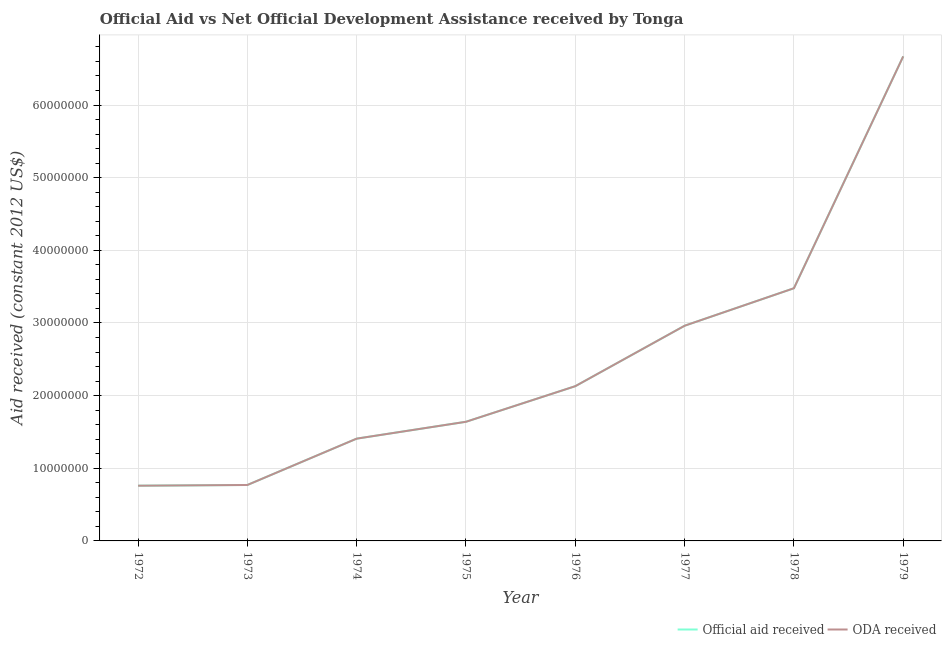How many different coloured lines are there?
Ensure brevity in your answer.  2. Does the line corresponding to official aid received intersect with the line corresponding to oda received?
Ensure brevity in your answer.  Yes. What is the official aid received in 1974?
Your answer should be compact. 1.41e+07. Across all years, what is the maximum official aid received?
Ensure brevity in your answer.  6.67e+07. Across all years, what is the minimum official aid received?
Offer a terse response. 7.60e+06. In which year was the official aid received maximum?
Offer a very short reply. 1979. What is the total official aid received in the graph?
Provide a succinct answer. 1.98e+08. What is the difference between the official aid received in 1974 and that in 1975?
Provide a succinct answer. -2.32e+06. What is the difference between the oda received in 1973 and the official aid received in 1978?
Provide a short and direct response. -2.71e+07. What is the average oda received per year?
Make the answer very short. 2.48e+07. In the year 1978, what is the difference between the oda received and official aid received?
Your answer should be very brief. 0. What is the ratio of the official aid received in 1972 to that in 1978?
Your answer should be compact. 0.22. Is the oda received in 1976 less than that in 1977?
Your response must be concise. Yes. Is the difference between the official aid received in 1974 and 1978 greater than the difference between the oda received in 1974 and 1978?
Your answer should be compact. No. What is the difference between the highest and the second highest oda received?
Keep it short and to the point. 3.19e+07. What is the difference between the highest and the lowest official aid received?
Offer a very short reply. 5.91e+07. Does the oda received monotonically increase over the years?
Offer a very short reply. Yes. Is the oda received strictly greater than the official aid received over the years?
Keep it short and to the point. No. Is the official aid received strictly less than the oda received over the years?
Your answer should be very brief. No. What is the difference between two consecutive major ticks on the Y-axis?
Your answer should be very brief. 1.00e+07. Does the graph contain grids?
Offer a very short reply. Yes. Where does the legend appear in the graph?
Your answer should be compact. Bottom right. What is the title of the graph?
Offer a terse response. Official Aid vs Net Official Development Assistance received by Tonga . What is the label or title of the Y-axis?
Provide a succinct answer. Aid received (constant 2012 US$). What is the Aid received (constant 2012 US$) in Official aid received in 1972?
Offer a terse response. 7.60e+06. What is the Aid received (constant 2012 US$) in ODA received in 1972?
Make the answer very short. 7.60e+06. What is the Aid received (constant 2012 US$) of Official aid received in 1973?
Offer a terse response. 7.70e+06. What is the Aid received (constant 2012 US$) in ODA received in 1973?
Your answer should be very brief. 7.70e+06. What is the Aid received (constant 2012 US$) of Official aid received in 1974?
Give a very brief answer. 1.41e+07. What is the Aid received (constant 2012 US$) of ODA received in 1974?
Offer a very short reply. 1.41e+07. What is the Aid received (constant 2012 US$) in Official aid received in 1975?
Provide a succinct answer. 1.64e+07. What is the Aid received (constant 2012 US$) of ODA received in 1975?
Ensure brevity in your answer.  1.64e+07. What is the Aid received (constant 2012 US$) in Official aid received in 1976?
Provide a succinct answer. 2.13e+07. What is the Aid received (constant 2012 US$) in ODA received in 1976?
Offer a very short reply. 2.13e+07. What is the Aid received (constant 2012 US$) of Official aid received in 1977?
Your answer should be very brief. 2.96e+07. What is the Aid received (constant 2012 US$) in ODA received in 1977?
Your answer should be very brief. 2.96e+07. What is the Aid received (constant 2012 US$) of Official aid received in 1978?
Offer a terse response. 3.48e+07. What is the Aid received (constant 2012 US$) in ODA received in 1978?
Your answer should be very brief. 3.48e+07. What is the Aid received (constant 2012 US$) of Official aid received in 1979?
Your answer should be very brief. 6.67e+07. What is the Aid received (constant 2012 US$) of ODA received in 1979?
Keep it short and to the point. 6.67e+07. Across all years, what is the maximum Aid received (constant 2012 US$) of Official aid received?
Your answer should be very brief. 6.67e+07. Across all years, what is the maximum Aid received (constant 2012 US$) in ODA received?
Your answer should be compact. 6.67e+07. Across all years, what is the minimum Aid received (constant 2012 US$) of Official aid received?
Offer a very short reply. 7.60e+06. Across all years, what is the minimum Aid received (constant 2012 US$) in ODA received?
Your answer should be very brief. 7.60e+06. What is the total Aid received (constant 2012 US$) in Official aid received in the graph?
Provide a short and direct response. 1.98e+08. What is the total Aid received (constant 2012 US$) in ODA received in the graph?
Ensure brevity in your answer.  1.98e+08. What is the difference between the Aid received (constant 2012 US$) in Official aid received in 1972 and that in 1974?
Offer a very short reply. -6.48e+06. What is the difference between the Aid received (constant 2012 US$) in ODA received in 1972 and that in 1974?
Ensure brevity in your answer.  -6.48e+06. What is the difference between the Aid received (constant 2012 US$) in Official aid received in 1972 and that in 1975?
Your response must be concise. -8.80e+06. What is the difference between the Aid received (constant 2012 US$) of ODA received in 1972 and that in 1975?
Your answer should be compact. -8.80e+06. What is the difference between the Aid received (constant 2012 US$) of Official aid received in 1972 and that in 1976?
Provide a short and direct response. -1.37e+07. What is the difference between the Aid received (constant 2012 US$) in ODA received in 1972 and that in 1976?
Offer a very short reply. -1.37e+07. What is the difference between the Aid received (constant 2012 US$) of Official aid received in 1972 and that in 1977?
Your answer should be very brief. -2.20e+07. What is the difference between the Aid received (constant 2012 US$) of ODA received in 1972 and that in 1977?
Your answer should be compact. -2.20e+07. What is the difference between the Aid received (constant 2012 US$) in Official aid received in 1972 and that in 1978?
Make the answer very short. -2.72e+07. What is the difference between the Aid received (constant 2012 US$) of ODA received in 1972 and that in 1978?
Make the answer very short. -2.72e+07. What is the difference between the Aid received (constant 2012 US$) in Official aid received in 1972 and that in 1979?
Keep it short and to the point. -5.91e+07. What is the difference between the Aid received (constant 2012 US$) in ODA received in 1972 and that in 1979?
Offer a terse response. -5.91e+07. What is the difference between the Aid received (constant 2012 US$) in Official aid received in 1973 and that in 1974?
Your response must be concise. -6.38e+06. What is the difference between the Aid received (constant 2012 US$) in ODA received in 1973 and that in 1974?
Your response must be concise. -6.38e+06. What is the difference between the Aid received (constant 2012 US$) of Official aid received in 1973 and that in 1975?
Ensure brevity in your answer.  -8.70e+06. What is the difference between the Aid received (constant 2012 US$) in ODA received in 1973 and that in 1975?
Provide a succinct answer. -8.70e+06. What is the difference between the Aid received (constant 2012 US$) in Official aid received in 1973 and that in 1976?
Provide a succinct answer. -1.36e+07. What is the difference between the Aid received (constant 2012 US$) in ODA received in 1973 and that in 1976?
Your answer should be compact. -1.36e+07. What is the difference between the Aid received (constant 2012 US$) of Official aid received in 1973 and that in 1977?
Provide a succinct answer. -2.19e+07. What is the difference between the Aid received (constant 2012 US$) of ODA received in 1973 and that in 1977?
Your answer should be very brief. -2.19e+07. What is the difference between the Aid received (constant 2012 US$) of Official aid received in 1973 and that in 1978?
Keep it short and to the point. -2.71e+07. What is the difference between the Aid received (constant 2012 US$) in ODA received in 1973 and that in 1978?
Offer a terse response. -2.71e+07. What is the difference between the Aid received (constant 2012 US$) of Official aid received in 1973 and that in 1979?
Provide a short and direct response. -5.90e+07. What is the difference between the Aid received (constant 2012 US$) in ODA received in 1973 and that in 1979?
Offer a very short reply. -5.90e+07. What is the difference between the Aid received (constant 2012 US$) in Official aid received in 1974 and that in 1975?
Ensure brevity in your answer.  -2.32e+06. What is the difference between the Aid received (constant 2012 US$) of ODA received in 1974 and that in 1975?
Give a very brief answer. -2.32e+06. What is the difference between the Aid received (constant 2012 US$) in Official aid received in 1974 and that in 1976?
Ensure brevity in your answer.  -7.22e+06. What is the difference between the Aid received (constant 2012 US$) of ODA received in 1974 and that in 1976?
Keep it short and to the point. -7.22e+06. What is the difference between the Aid received (constant 2012 US$) in Official aid received in 1974 and that in 1977?
Ensure brevity in your answer.  -1.55e+07. What is the difference between the Aid received (constant 2012 US$) of ODA received in 1974 and that in 1977?
Give a very brief answer. -1.55e+07. What is the difference between the Aid received (constant 2012 US$) of Official aid received in 1974 and that in 1978?
Keep it short and to the point. -2.07e+07. What is the difference between the Aid received (constant 2012 US$) of ODA received in 1974 and that in 1978?
Ensure brevity in your answer.  -2.07e+07. What is the difference between the Aid received (constant 2012 US$) in Official aid received in 1974 and that in 1979?
Give a very brief answer. -5.26e+07. What is the difference between the Aid received (constant 2012 US$) in ODA received in 1974 and that in 1979?
Offer a terse response. -5.26e+07. What is the difference between the Aid received (constant 2012 US$) of Official aid received in 1975 and that in 1976?
Offer a very short reply. -4.90e+06. What is the difference between the Aid received (constant 2012 US$) of ODA received in 1975 and that in 1976?
Your answer should be very brief. -4.90e+06. What is the difference between the Aid received (constant 2012 US$) of Official aid received in 1975 and that in 1977?
Offer a terse response. -1.32e+07. What is the difference between the Aid received (constant 2012 US$) of ODA received in 1975 and that in 1977?
Offer a very short reply. -1.32e+07. What is the difference between the Aid received (constant 2012 US$) of Official aid received in 1975 and that in 1978?
Provide a succinct answer. -1.84e+07. What is the difference between the Aid received (constant 2012 US$) in ODA received in 1975 and that in 1978?
Your answer should be compact. -1.84e+07. What is the difference between the Aid received (constant 2012 US$) of Official aid received in 1975 and that in 1979?
Offer a terse response. -5.03e+07. What is the difference between the Aid received (constant 2012 US$) of ODA received in 1975 and that in 1979?
Offer a terse response. -5.03e+07. What is the difference between the Aid received (constant 2012 US$) of Official aid received in 1976 and that in 1977?
Ensure brevity in your answer.  -8.32e+06. What is the difference between the Aid received (constant 2012 US$) of ODA received in 1976 and that in 1977?
Provide a short and direct response. -8.32e+06. What is the difference between the Aid received (constant 2012 US$) of Official aid received in 1976 and that in 1978?
Give a very brief answer. -1.35e+07. What is the difference between the Aid received (constant 2012 US$) of ODA received in 1976 and that in 1978?
Ensure brevity in your answer.  -1.35e+07. What is the difference between the Aid received (constant 2012 US$) in Official aid received in 1976 and that in 1979?
Offer a terse response. -4.54e+07. What is the difference between the Aid received (constant 2012 US$) in ODA received in 1976 and that in 1979?
Your response must be concise. -4.54e+07. What is the difference between the Aid received (constant 2012 US$) of Official aid received in 1977 and that in 1978?
Offer a very short reply. -5.16e+06. What is the difference between the Aid received (constant 2012 US$) of ODA received in 1977 and that in 1978?
Provide a short and direct response. -5.16e+06. What is the difference between the Aid received (constant 2012 US$) of Official aid received in 1977 and that in 1979?
Your response must be concise. -3.71e+07. What is the difference between the Aid received (constant 2012 US$) in ODA received in 1977 and that in 1979?
Offer a very short reply. -3.71e+07. What is the difference between the Aid received (constant 2012 US$) of Official aid received in 1978 and that in 1979?
Make the answer very short. -3.19e+07. What is the difference between the Aid received (constant 2012 US$) of ODA received in 1978 and that in 1979?
Make the answer very short. -3.19e+07. What is the difference between the Aid received (constant 2012 US$) in Official aid received in 1972 and the Aid received (constant 2012 US$) in ODA received in 1973?
Give a very brief answer. -1.00e+05. What is the difference between the Aid received (constant 2012 US$) of Official aid received in 1972 and the Aid received (constant 2012 US$) of ODA received in 1974?
Provide a succinct answer. -6.48e+06. What is the difference between the Aid received (constant 2012 US$) of Official aid received in 1972 and the Aid received (constant 2012 US$) of ODA received in 1975?
Ensure brevity in your answer.  -8.80e+06. What is the difference between the Aid received (constant 2012 US$) in Official aid received in 1972 and the Aid received (constant 2012 US$) in ODA received in 1976?
Ensure brevity in your answer.  -1.37e+07. What is the difference between the Aid received (constant 2012 US$) in Official aid received in 1972 and the Aid received (constant 2012 US$) in ODA received in 1977?
Give a very brief answer. -2.20e+07. What is the difference between the Aid received (constant 2012 US$) of Official aid received in 1972 and the Aid received (constant 2012 US$) of ODA received in 1978?
Make the answer very short. -2.72e+07. What is the difference between the Aid received (constant 2012 US$) in Official aid received in 1972 and the Aid received (constant 2012 US$) in ODA received in 1979?
Give a very brief answer. -5.91e+07. What is the difference between the Aid received (constant 2012 US$) of Official aid received in 1973 and the Aid received (constant 2012 US$) of ODA received in 1974?
Your response must be concise. -6.38e+06. What is the difference between the Aid received (constant 2012 US$) of Official aid received in 1973 and the Aid received (constant 2012 US$) of ODA received in 1975?
Your response must be concise. -8.70e+06. What is the difference between the Aid received (constant 2012 US$) of Official aid received in 1973 and the Aid received (constant 2012 US$) of ODA received in 1976?
Offer a terse response. -1.36e+07. What is the difference between the Aid received (constant 2012 US$) of Official aid received in 1973 and the Aid received (constant 2012 US$) of ODA received in 1977?
Your response must be concise. -2.19e+07. What is the difference between the Aid received (constant 2012 US$) in Official aid received in 1973 and the Aid received (constant 2012 US$) in ODA received in 1978?
Your answer should be compact. -2.71e+07. What is the difference between the Aid received (constant 2012 US$) in Official aid received in 1973 and the Aid received (constant 2012 US$) in ODA received in 1979?
Your answer should be very brief. -5.90e+07. What is the difference between the Aid received (constant 2012 US$) in Official aid received in 1974 and the Aid received (constant 2012 US$) in ODA received in 1975?
Your answer should be compact. -2.32e+06. What is the difference between the Aid received (constant 2012 US$) of Official aid received in 1974 and the Aid received (constant 2012 US$) of ODA received in 1976?
Your response must be concise. -7.22e+06. What is the difference between the Aid received (constant 2012 US$) of Official aid received in 1974 and the Aid received (constant 2012 US$) of ODA received in 1977?
Make the answer very short. -1.55e+07. What is the difference between the Aid received (constant 2012 US$) of Official aid received in 1974 and the Aid received (constant 2012 US$) of ODA received in 1978?
Your answer should be very brief. -2.07e+07. What is the difference between the Aid received (constant 2012 US$) in Official aid received in 1974 and the Aid received (constant 2012 US$) in ODA received in 1979?
Your response must be concise. -5.26e+07. What is the difference between the Aid received (constant 2012 US$) of Official aid received in 1975 and the Aid received (constant 2012 US$) of ODA received in 1976?
Provide a succinct answer. -4.90e+06. What is the difference between the Aid received (constant 2012 US$) of Official aid received in 1975 and the Aid received (constant 2012 US$) of ODA received in 1977?
Make the answer very short. -1.32e+07. What is the difference between the Aid received (constant 2012 US$) in Official aid received in 1975 and the Aid received (constant 2012 US$) in ODA received in 1978?
Give a very brief answer. -1.84e+07. What is the difference between the Aid received (constant 2012 US$) in Official aid received in 1975 and the Aid received (constant 2012 US$) in ODA received in 1979?
Your answer should be compact. -5.03e+07. What is the difference between the Aid received (constant 2012 US$) of Official aid received in 1976 and the Aid received (constant 2012 US$) of ODA received in 1977?
Keep it short and to the point. -8.32e+06. What is the difference between the Aid received (constant 2012 US$) of Official aid received in 1976 and the Aid received (constant 2012 US$) of ODA received in 1978?
Provide a succinct answer. -1.35e+07. What is the difference between the Aid received (constant 2012 US$) in Official aid received in 1976 and the Aid received (constant 2012 US$) in ODA received in 1979?
Offer a terse response. -4.54e+07. What is the difference between the Aid received (constant 2012 US$) of Official aid received in 1977 and the Aid received (constant 2012 US$) of ODA received in 1978?
Make the answer very short. -5.16e+06. What is the difference between the Aid received (constant 2012 US$) in Official aid received in 1977 and the Aid received (constant 2012 US$) in ODA received in 1979?
Provide a succinct answer. -3.71e+07. What is the difference between the Aid received (constant 2012 US$) of Official aid received in 1978 and the Aid received (constant 2012 US$) of ODA received in 1979?
Give a very brief answer. -3.19e+07. What is the average Aid received (constant 2012 US$) in Official aid received per year?
Keep it short and to the point. 2.48e+07. What is the average Aid received (constant 2012 US$) in ODA received per year?
Your answer should be very brief. 2.48e+07. In the year 1977, what is the difference between the Aid received (constant 2012 US$) in Official aid received and Aid received (constant 2012 US$) in ODA received?
Offer a very short reply. 0. In the year 1979, what is the difference between the Aid received (constant 2012 US$) in Official aid received and Aid received (constant 2012 US$) in ODA received?
Ensure brevity in your answer.  0. What is the ratio of the Aid received (constant 2012 US$) in Official aid received in 1972 to that in 1974?
Offer a very short reply. 0.54. What is the ratio of the Aid received (constant 2012 US$) in ODA received in 1972 to that in 1974?
Ensure brevity in your answer.  0.54. What is the ratio of the Aid received (constant 2012 US$) of Official aid received in 1972 to that in 1975?
Your response must be concise. 0.46. What is the ratio of the Aid received (constant 2012 US$) in ODA received in 1972 to that in 1975?
Give a very brief answer. 0.46. What is the ratio of the Aid received (constant 2012 US$) in Official aid received in 1972 to that in 1976?
Offer a terse response. 0.36. What is the ratio of the Aid received (constant 2012 US$) in ODA received in 1972 to that in 1976?
Keep it short and to the point. 0.36. What is the ratio of the Aid received (constant 2012 US$) of Official aid received in 1972 to that in 1977?
Give a very brief answer. 0.26. What is the ratio of the Aid received (constant 2012 US$) in ODA received in 1972 to that in 1977?
Offer a very short reply. 0.26. What is the ratio of the Aid received (constant 2012 US$) in Official aid received in 1972 to that in 1978?
Offer a very short reply. 0.22. What is the ratio of the Aid received (constant 2012 US$) of ODA received in 1972 to that in 1978?
Offer a very short reply. 0.22. What is the ratio of the Aid received (constant 2012 US$) of Official aid received in 1972 to that in 1979?
Offer a terse response. 0.11. What is the ratio of the Aid received (constant 2012 US$) in ODA received in 1972 to that in 1979?
Provide a succinct answer. 0.11. What is the ratio of the Aid received (constant 2012 US$) of Official aid received in 1973 to that in 1974?
Offer a very short reply. 0.55. What is the ratio of the Aid received (constant 2012 US$) in ODA received in 1973 to that in 1974?
Your response must be concise. 0.55. What is the ratio of the Aid received (constant 2012 US$) of Official aid received in 1973 to that in 1975?
Your answer should be compact. 0.47. What is the ratio of the Aid received (constant 2012 US$) in ODA received in 1973 to that in 1975?
Your answer should be very brief. 0.47. What is the ratio of the Aid received (constant 2012 US$) of Official aid received in 1973 to that in 1976?
Offer a terse response. 0.36. What is the ratio of the Aid received (constant 2012 US$) in ODA received in 1973 to that in 1976?
Give a very brief answer. 0.36. What is the ratio of the Aid received (constant 2012 US$) in Official aid received in 1973 to that in 1977?
Provide a succinct answer. 0.26. What is the ratio of the Aid received (constant 2012 US$) of ODA received in 1973 to that in 1977?
Your answer should be compact. 0.26. What is the ratio of the Aid received (constant 2012 US$) of Official aid received in 1973 to that in 1978?
Ensure brevity in your answer.  0.22. What is the ratio of the Aid received (constant 2012 US$) in ODA received in 1973 to that in 1978?
Your response must be concise. 0.22. What is the ratio of the Aid received (constant 2012 US$) of Official aid received in 1973 to that in 1979?
Your response must be concise. 0.12. What is the ratio of the Aid received (constant 2012 US$) of ODA received in 1973 to that in 1979?
Give a very brief answer. 0.12. What is the ratio of the Aid received (constant 2012 US$) in Official aid received in 1974 to that in 1975?
Your answer should be compact. 0.86. What is the ratio of the Aid received (constant 2012 US$) in ODA received in 1974 to that in 1975?
Make the answer very short. 0.86. What is the ratio of the Aid received (constant 2012 US$) in Official aid received in 1974 to that in 1976?
Keep it short and to the point. 0.66. What is the ratio of the Aid received (constant 2012 US$) of ODA received in 1974 to that in 1976?
Your answer should be compact. 0.66. What is the ratio of the Aid received (constant 2012 US$) in Official aid received in 1974 to that in 1977?
Provide a short and direct response. 0.48. What is the ratio of the Aid received (constant 2012 US$) in ODA received in 1974 to that in 1977?
Your response must be concise. 0.48. What is the ratio of the Aid received (constant 2012 US$) of Official aid received in 1974 to that in 1978?
Your answer should be compact. 0.4. What is the ratio of the Aid received (constant 2012 US$) in ODA received in 1974 to that in 1978?
Make the answer very short. 0.4. What is the ratio of the Aid received (constant 2012 US$) of Official aid received in 1974 to that in 1979?
Provide a short and direct response. 0.21. What is the ratio of the Aid received (constant 2012 US$) of ODA received in 1974 to that in 1979?
Offer a terse response. 0.21. What is the ratio of the Aid received (constant 2012 US$) in Official aid received in 1975 to that in 1976?
Your answer should be very brief. 0.77. What is the ratio of the Aid received (constant 2012 US$) of ODA received in 1975 to that in 1976?
Your answer should be very brief. 0.77. What is the ratio of the Aid received (constant 2012 US$) of Official aid received in 1975 to that in 1977?
Provide a succinct answer. 0.55. What is the ratio of the Aid received (constant 2012 US$) of ODA received in 1975 to that in 1977?
Keep it short and to the point. 0.55. What is the ratio of the Aid received (constant 2012 US$) in Official aid received in 1975 to that in 1978?
Your answer should be compact. 0.47. What is the ratio of the Aid received (constant 2012 US$) of ODA received in 1975 to that in 1978?
Keep it short and to the point. 0.47. What is the ratio of the Aid received (constant 2012 US$) in Official aid received in 1975 to that in 1979?
Provide a succinct answer. 0.25. What is the ratio of the Aid received (constant 2012 US$) in ODA received in 1975 to that in 1979?
Offer a terse response. 0.25. What is the ratio of the Aid received (constant 2012 US$) of Official aid received in 1976 to that in 1977?
Offer a very short reply. 0.72. What is the ratio of the Aid received (constant 2012 US$) in ODA received in 1976 to that in 1977?
Offer a terse response. 0.72. What is the ratio of the Aid received (constant 2012 US$) in Official aid received in 1976 to that in 1978?
Offer a very short reply. 0.61. What is the ratio of the Aid received (constant 2012 US$) of ODA received in 1976 to that in 1978?
Make the answer very short. 0.61. What is the ratio of the Aid received (constant 2012 US$) of Official aid received in 1976 to that in 1979?
Make the answer very short. 0.32. What is the ratio of the Aid received (constant 2012 US$) in ODA received in 1976 to that in 1979?
Provide a succinct answer. 0.32. What is the ratio of the Aid received (constant 2012 US$) in Official aid received in 1977 to that in 1978?
Your response must be concise. 0.85. What is the ratio of the Aid received (constant 2012 US$) of ODA received in 1977 to that in 1978?
Your answer should be very brief. 0.85. What is the ratio of the Aid received (constant 2012 US$) in Official aid received in 1977 to that in 1979?
Provide a short and direct response. 0.44. What is the ratio of the Aid received (constant 2012 US$) in ODA received in 1977 to that in 1979?
Make the answer very short. 0.44. What is the ratio of the Aid received (constant 2012 US$) in Official aid received in 1978 to that in 1979?
Your response must be concise. 0.52. What is the ratio of the Aid received (constant 2012 US$) in ODA received in 1978 to that in 1979?
Your answer should be very brief. 0.52. What is the difference between the highest and the second highest Aid received (constant 2012 US$) of Official aid received?
Offer a terse response. 3.19e+07. What is the difference between the highest and the second highest Aid received (constant 2012 US$) of ODA received?
Provide a short and direct response. 3.19e+07. What is the difference between the highest and the lowest Aid received (constant 2012 US$) of Official aid received?
Provide a short and direct response. 5.91e+07. What is the difference between the highest and the lowest Aid received (constant 2012 US$) in ODA received?
Offer a very short reply. 5.91e+07. 